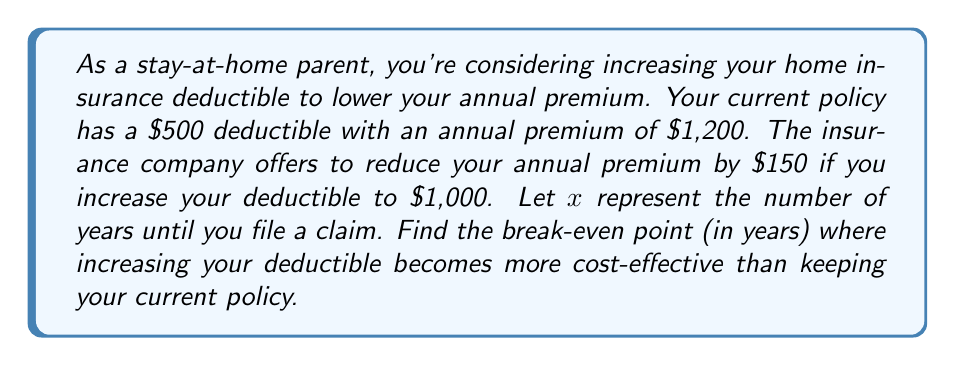Could you help me with this problem? To solve this problem, we need to compare the total cost of both options over time and find the point where they become equal. Let's break it down step-by-step:

1. Set up the cost functions:
   - Current policy: $f(x) = 1200x + 500$
   - New policy: $g(x) = 1050x + 1000$

   Where $x$ is the number of years and the constant term represents the deductible.

2. To find the break-even point, we set the two functions equal to each other:
   $$f(x) = g(x)$$
   $$1200x + 500 = 1050x + 1000$$

3. Solve for $x$:
   $$1200x - 1050x = 1000 - 500$$
   $$150x = 500$$
   $$x = \frac{500}{150} = \frac{10}{3} \approx 3.33$$

4. Interpret the result:
   The break-even point occurs at approximately 3.33 years. This means:
   - If you file a claim before 3.33 years, keeping the current policy is more cost-effective.
   - If you file a claim after 3.33 years, increasing the deductible is more cost-effective.

5. Verify the result:
   At $x = \frac{10}{3}$ years:
   $$f(\frac{10}{3}) = 1200 \cdot \frac{10}{3} + 500 = 4000 + 500 = 4500$$
   $$g(\frac{10}{3}) = 1050 \cdot \frac{10}{3} + 1000 = 3500 + 1000 = 4500$$

   This confirms that both options have the same total cost at the break-even point.
Answer: The break-even point is $\frac{10}{3}$ years (approximately 3.33 years). 